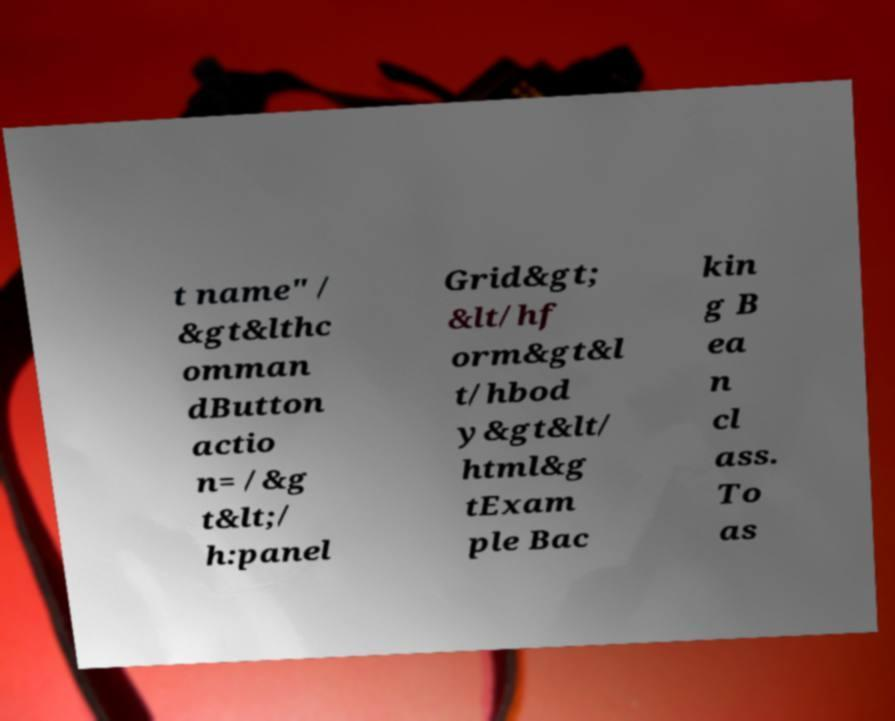There's text embedded in this image that I need extracted. Can you transcribe it verbatim? t name" / &gt&lthc omman dButton actio n= /&g t&lt;/ h:panel Grid&gt; &lt/hf orm&gt&l t/hbod y&gt&lt/ html&g tExam ple Bac kin g B ea n cl ass. To as 